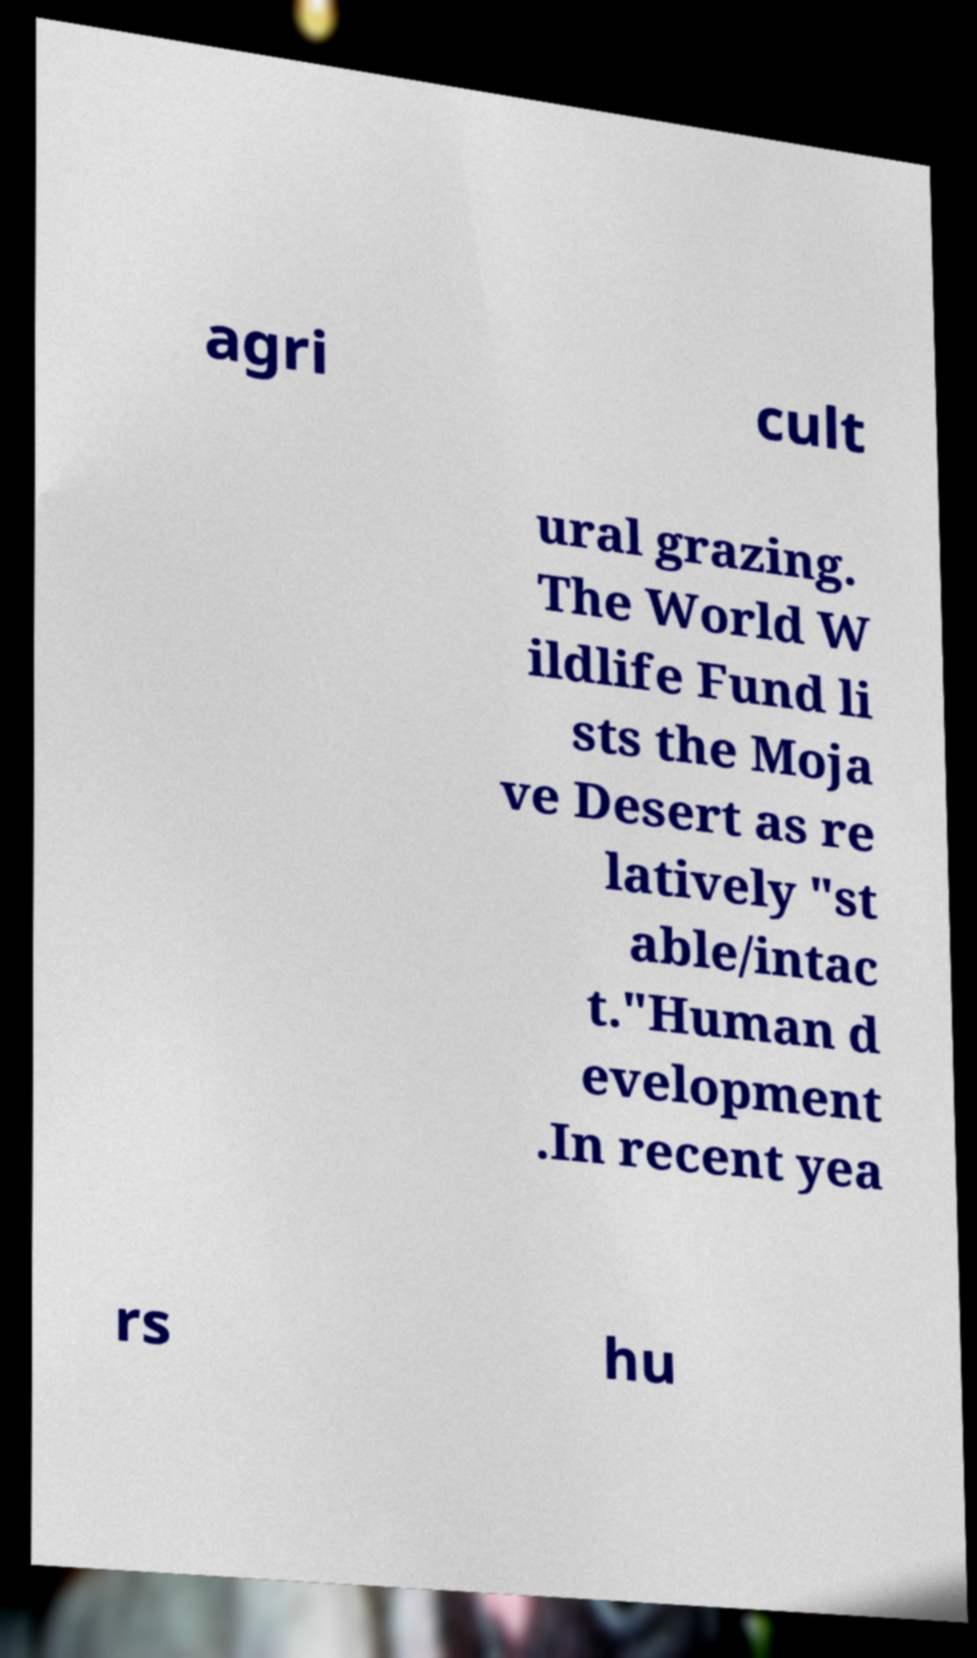Please identify and transcribe the text found in this image. agri cult ural grazing. The World W ildlife Fund li sts the Moja ve Desert as re latively "st able/intac t."Human d evelopment .In recent yea rs hu 